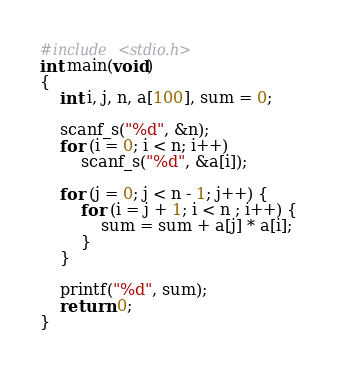Convert code to text. <code><loc_0><loc_0><loc_500><loc_500><_C_>#include <stdio.h>
int main(void)
{
	int i, j, n, a[100], sum = 0;

	scanf_s("%d", &n);
	for (i = 0; i < n; i++)
		scanf_s("%d", &a[i]);

	for (j = 0; j < n - 1; j++) {
		for (i = j + 1; i < n ; i++) {
			sum = sum + a[j] * a[i];
		}
	}

	printf("%d", sum);
	return 0;
}</code> 